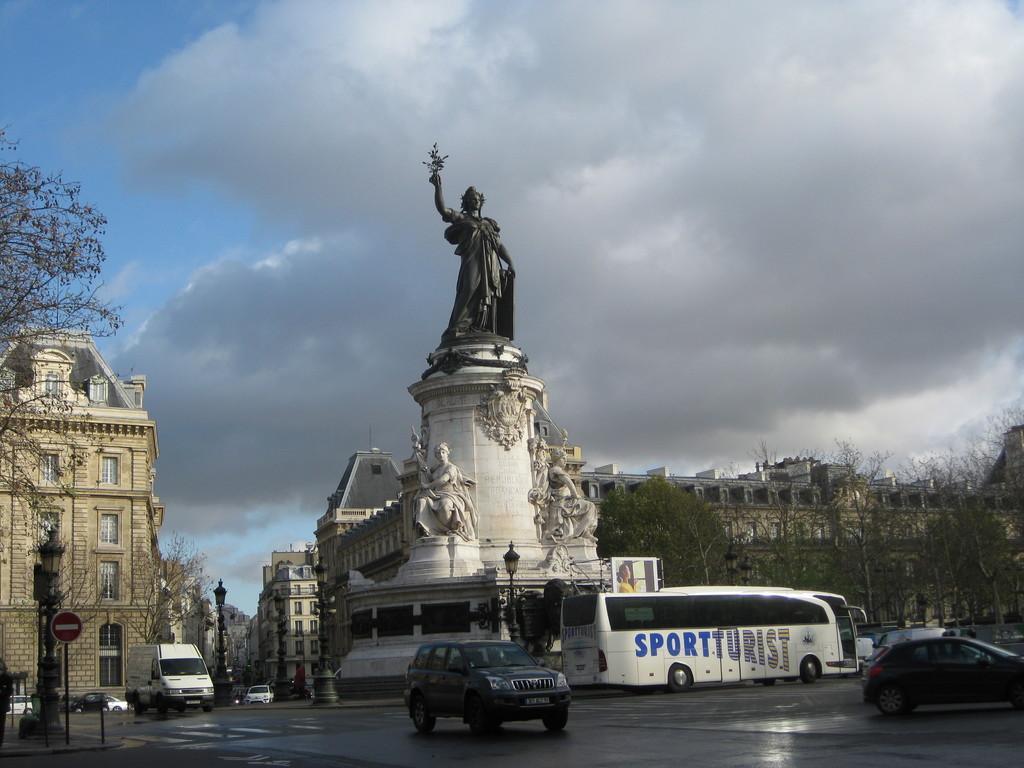How would you summarize this image in a sentence or two? In this image, on the right side, we can see a car which is moving on the road. In the middle of the image, we can also see another car moving, on the left side, we can see some trees and a vehicle's, pole, buildings, glass windows. In the background, we can see a statue, buildings, trees. At the top, we can see a sky, at the bottom, we can see a road. 